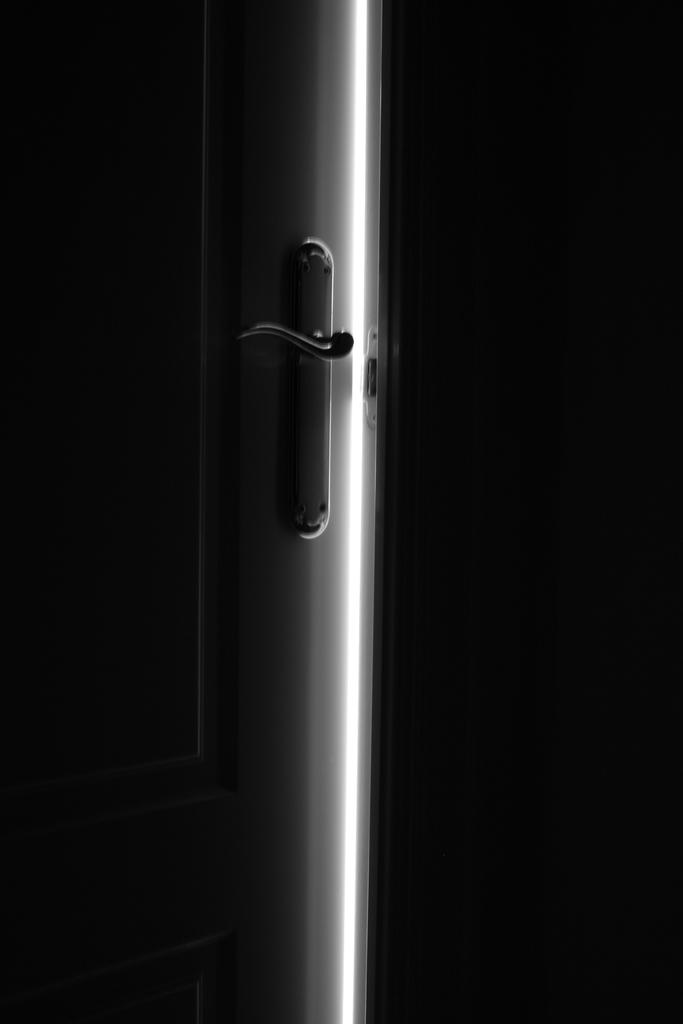What can be seen on the door in the image? There is a door handle in the image. What type of structure is visible in the image? There is a wall in the image. Is the friend standing next to the door handle in the image? There is no friend present in the image; it only shows a door handle and a wall. 